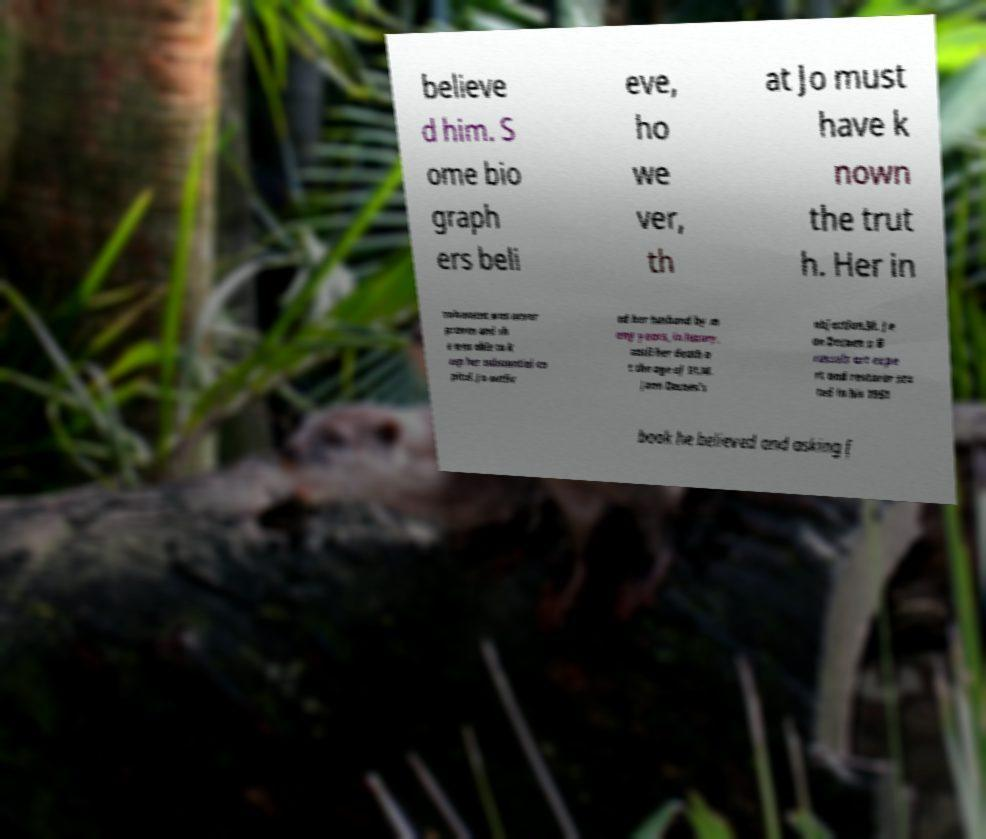Can you read and provide the text displayed in the image?This photo seems to have some interesting text. Can you extract and type it out for me? believe d him. S ome bio graph ers beli eve, ho we ver, th at Jo must have k nown the trut h. Her in volvement was never proven and sh e was able to k eep her substantial ca pital. Jo outliv ed her husband by m any years, in luxury, until her death a t the age of 91.M. Jean Decoen's objection.M. Je an Decoen a B russels art expe rt and restorer sta ted in his 1951 book he believed and asking f 